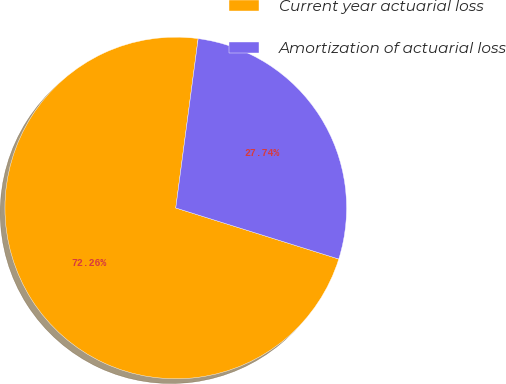<chart> <loc_0><loc_0><loc_500><loc_500><pie_chart><fcel>Current year actuarial loss<fcel>Amortization of actuarial loss<nl><fcel>72.26%<fcel>27.74%<nl></chart> 